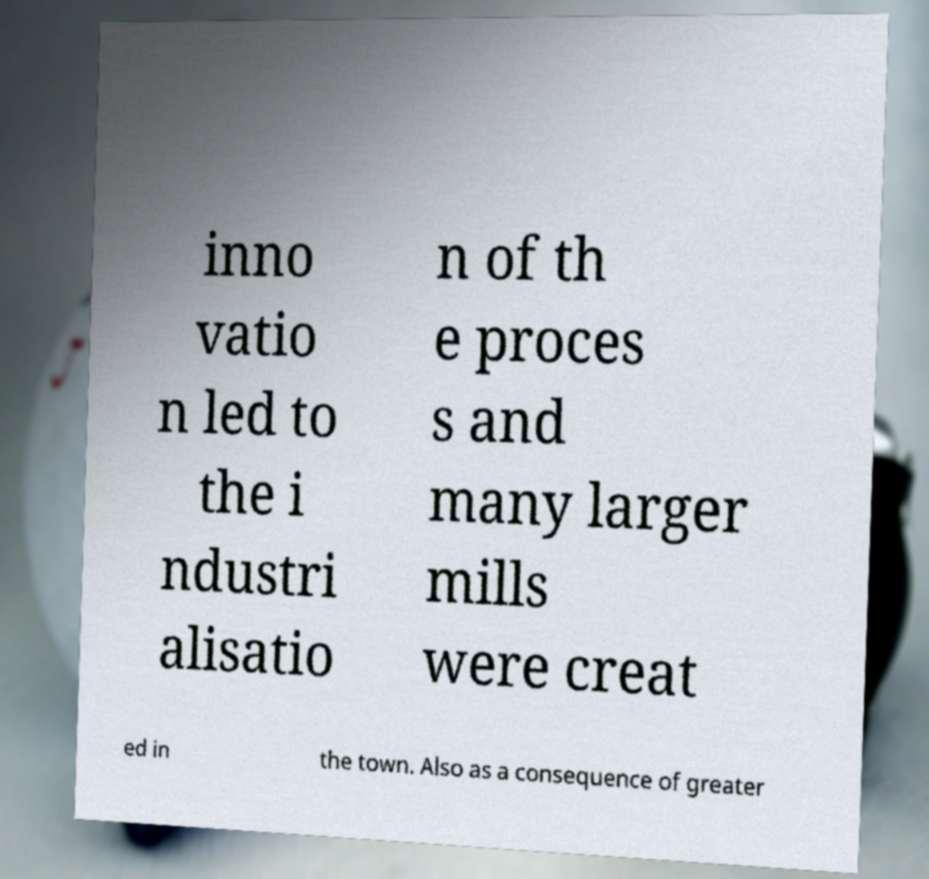There's text embedded in this image that I need extracted. Can you transcribe it verbatim? inno vatio n led to the i ndustri alisatio n of th e proces s and many larger mills were creat ed in the town. Also as a consequence of greater 